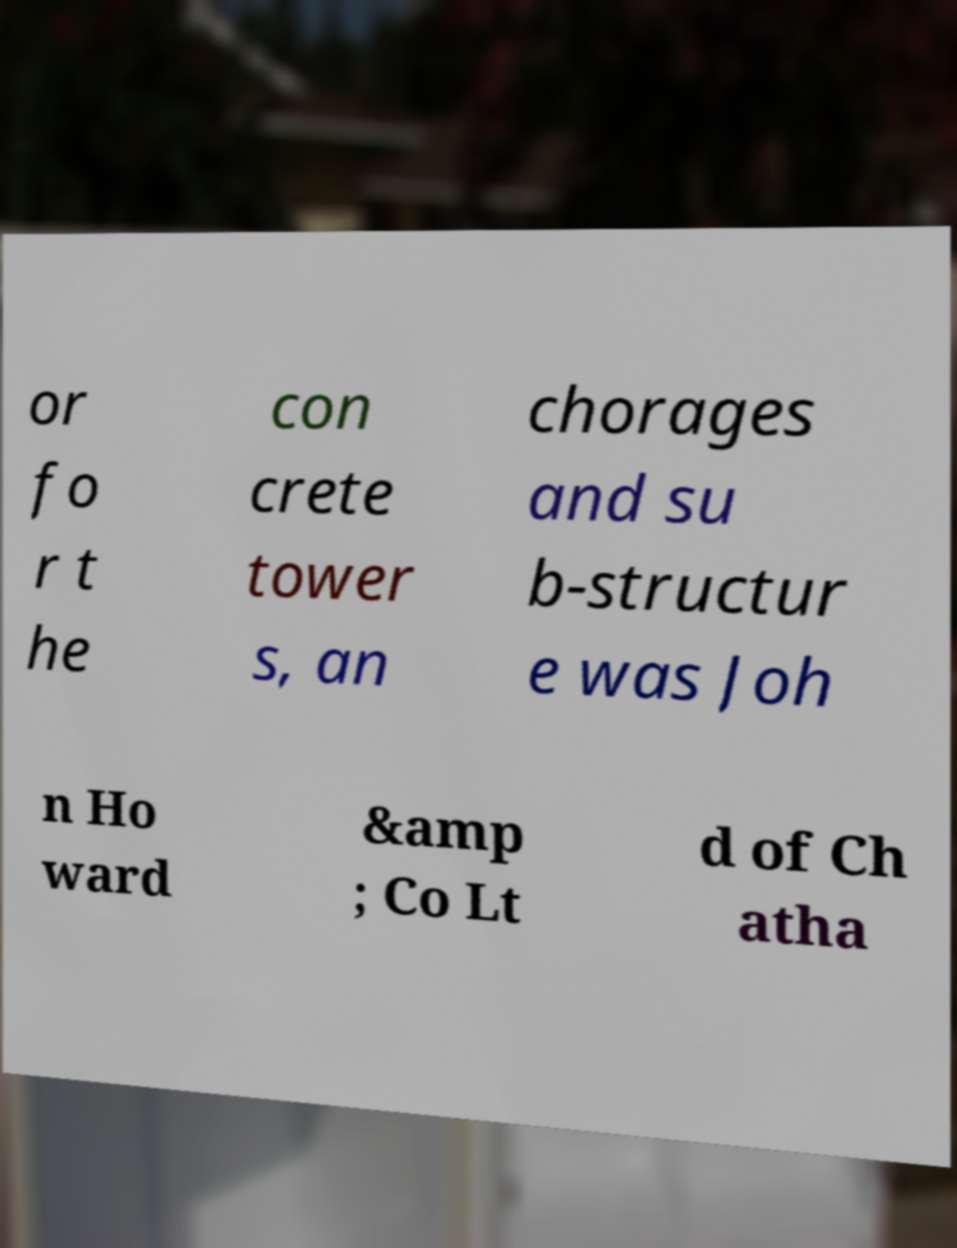Can you read and provide the text displayed in the image?This photo seems to have some interesting text. Can you extract and type it out for me? or fo r t he con crete tower s, an chorages and su b-structur e was Joh n Ho ward &amp ; Co Lt d of Ch atha 